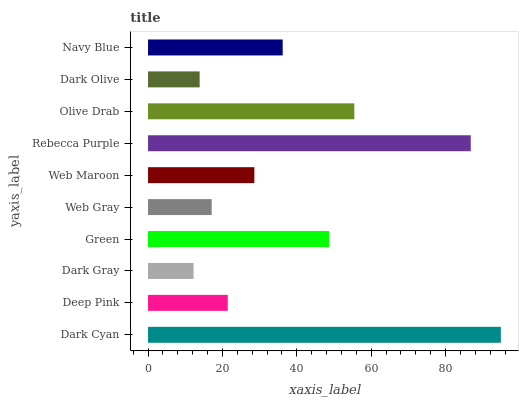Is Dark Gray the minimum?
Answer yes or no. Yes. Is Dark Cyan the maximum?
Answer yes or no. Yes. Is Deep Pink the minimum?
Answer yes or no. No. Is Deep Pink the maximum?
Answer yes or no. No. Is Dark Cyan greater than Deep Pink?
Answer yes or no. Yes. Is Deep Pink less than Dark Cyan?
Answer yes or no. Yes. Is Deep Pink greater than Dark Cyan?
Answer yes or no. No. Is Dark Cyan less than Deep Pink?
Answer yes or no. No. Is Navy Blue the high median?
Answer yes or no. Yes. Is Web Maroon the low median?
Answer yes or no. Yes. Is Web Gray the high median?
Answer yes or no. No. Is Dark Olive the low median?
Answer yes or no. No. 